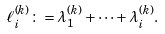<formula> <loc_0><loc_0><loc_500><loc_500>\ell _ { i } ^ { ( k ) } \colon = \lambda _ { 1 } ^ { ( k ) } + \cdots + \lambda _ { i } ^ { ( k ) } .</formula> 